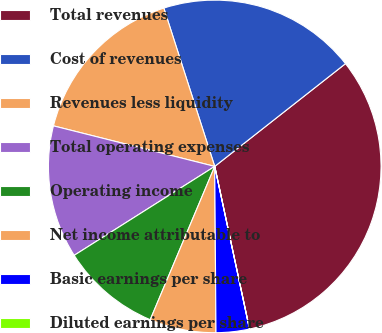Convert chart. <chart><loc_0><loc_0><loc_500><loc_500><pie_chart><fcel>Total revenues<fcel>Cost of revenues<fcel>Revenues less liquidity<fcel>Total operating expenses<fcel>Operating income<fcel>Net income attributable to<fcel>Basic earnings per share<fcel>Diluted earnings per share<nl><fcel>32.24%<fcel>19.35%<fcel>16.13%<fcel>12.9%<fcel>9.68%<fcel>6.46%<fcel>3.23%<fcel>0.01%<nl></chart> 